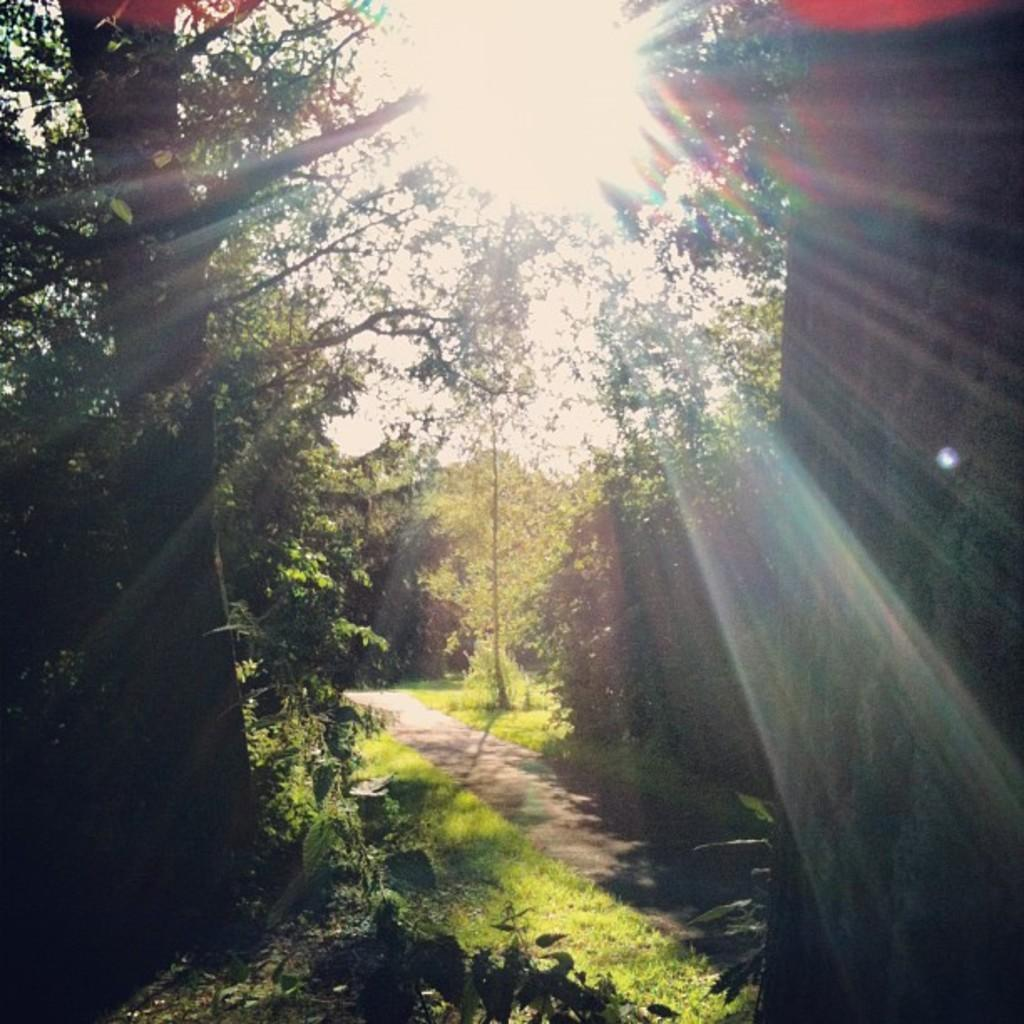What can be seen in the foreground of the image? There is a path in the foreground of the image. What is located on either side of the path? There are trees on either side of the path. What is visible at the top of the image? The sun and sky are visible at the top of the image. What type of scientific experiment is being conducted in the image? There is no indication of a scientific experiment being conducted in the image; it features a path with trees on either side and a visible sun and sky. 